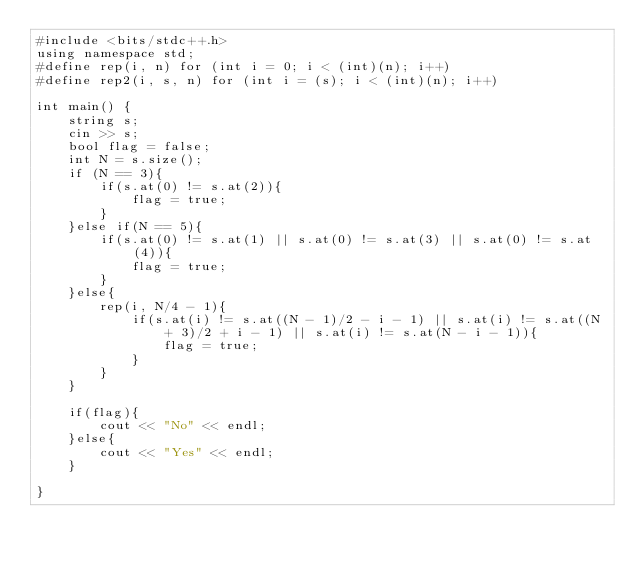<code> <loc_0><loc_0><loc_500><loc_500><_C++_>#include <bits/stdc++.h>
using namespace std;
#define rep(i, n) for (int i = 0; i < (int)(n); i++)
#define rep2(i, s, n) for (int i = (s); i < (int)(n); i++)

int main() {
    string s;
    cin >> s;
    bool flag = false;
    int N = s.size();
    if (N == 3){
        if(s.at(0) != s.at(2)){
            flag = true;
        }
    }else if(N == 5){
        if(s.at(0) != s.at(1) || s.at(0) != s.at(3) || s.at(0) != s.at(4)){
            flag = true;
        }
    }else{
        rep(i, N/4 - 1){
            if(s.at(i) != s.at((N - 1)/2 - i - 1) || s.at(i) != s.at((N + 3)/2 + i - 1) || s.at(i) != s.at(N - i - 1)){
                flag = true;
            }
        }
    }
    
    if(flag){
        cout << "No" << endl;
    }else{
        cout << "Yes" << endl;
    }

}
</code> 